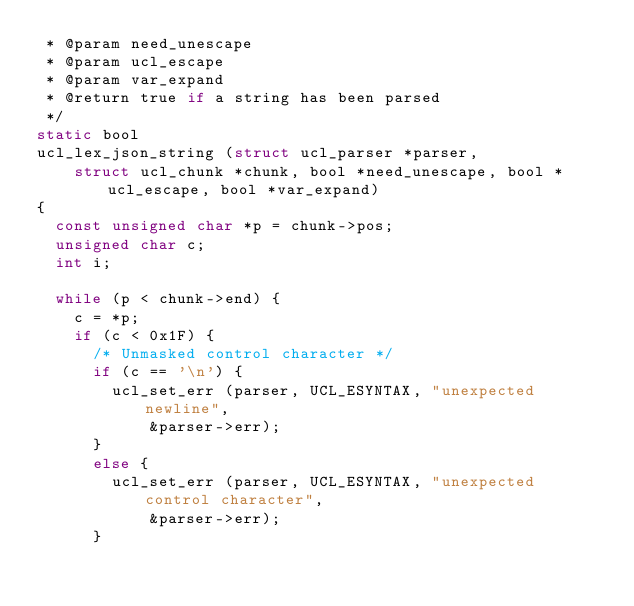<code> <loc_0><loc_0><loc_500><loc_500><_C_> * @param need_unescape
 * @param ucl_escape
 * @param var_expand
 * @return true if a string has been parsed
 */
static bool
ucl_lex_json_string (struct ucl_parser *parser,
		struct ucl_chunk *chunk, bool *need_unescape, bool *ucl_escape, bool *var_expand)
{
	const unsigned char *p = chunk->pos;
	unsigned char c;
	int i;

	while (p < chunk->end) {
		c = *p;
		if (c < 0x1F) {
			/* Unmasked control character */
			if (c == '\n') {
				ucl_set_err (parser, UCL_ESYNTAX, "unexpected newline",
						&parser->err);
			}
			else {
				ucl_set_err (parser, UCL_ESYNTAX, "unexpected control character",
						&parser->err);
			}</code> 